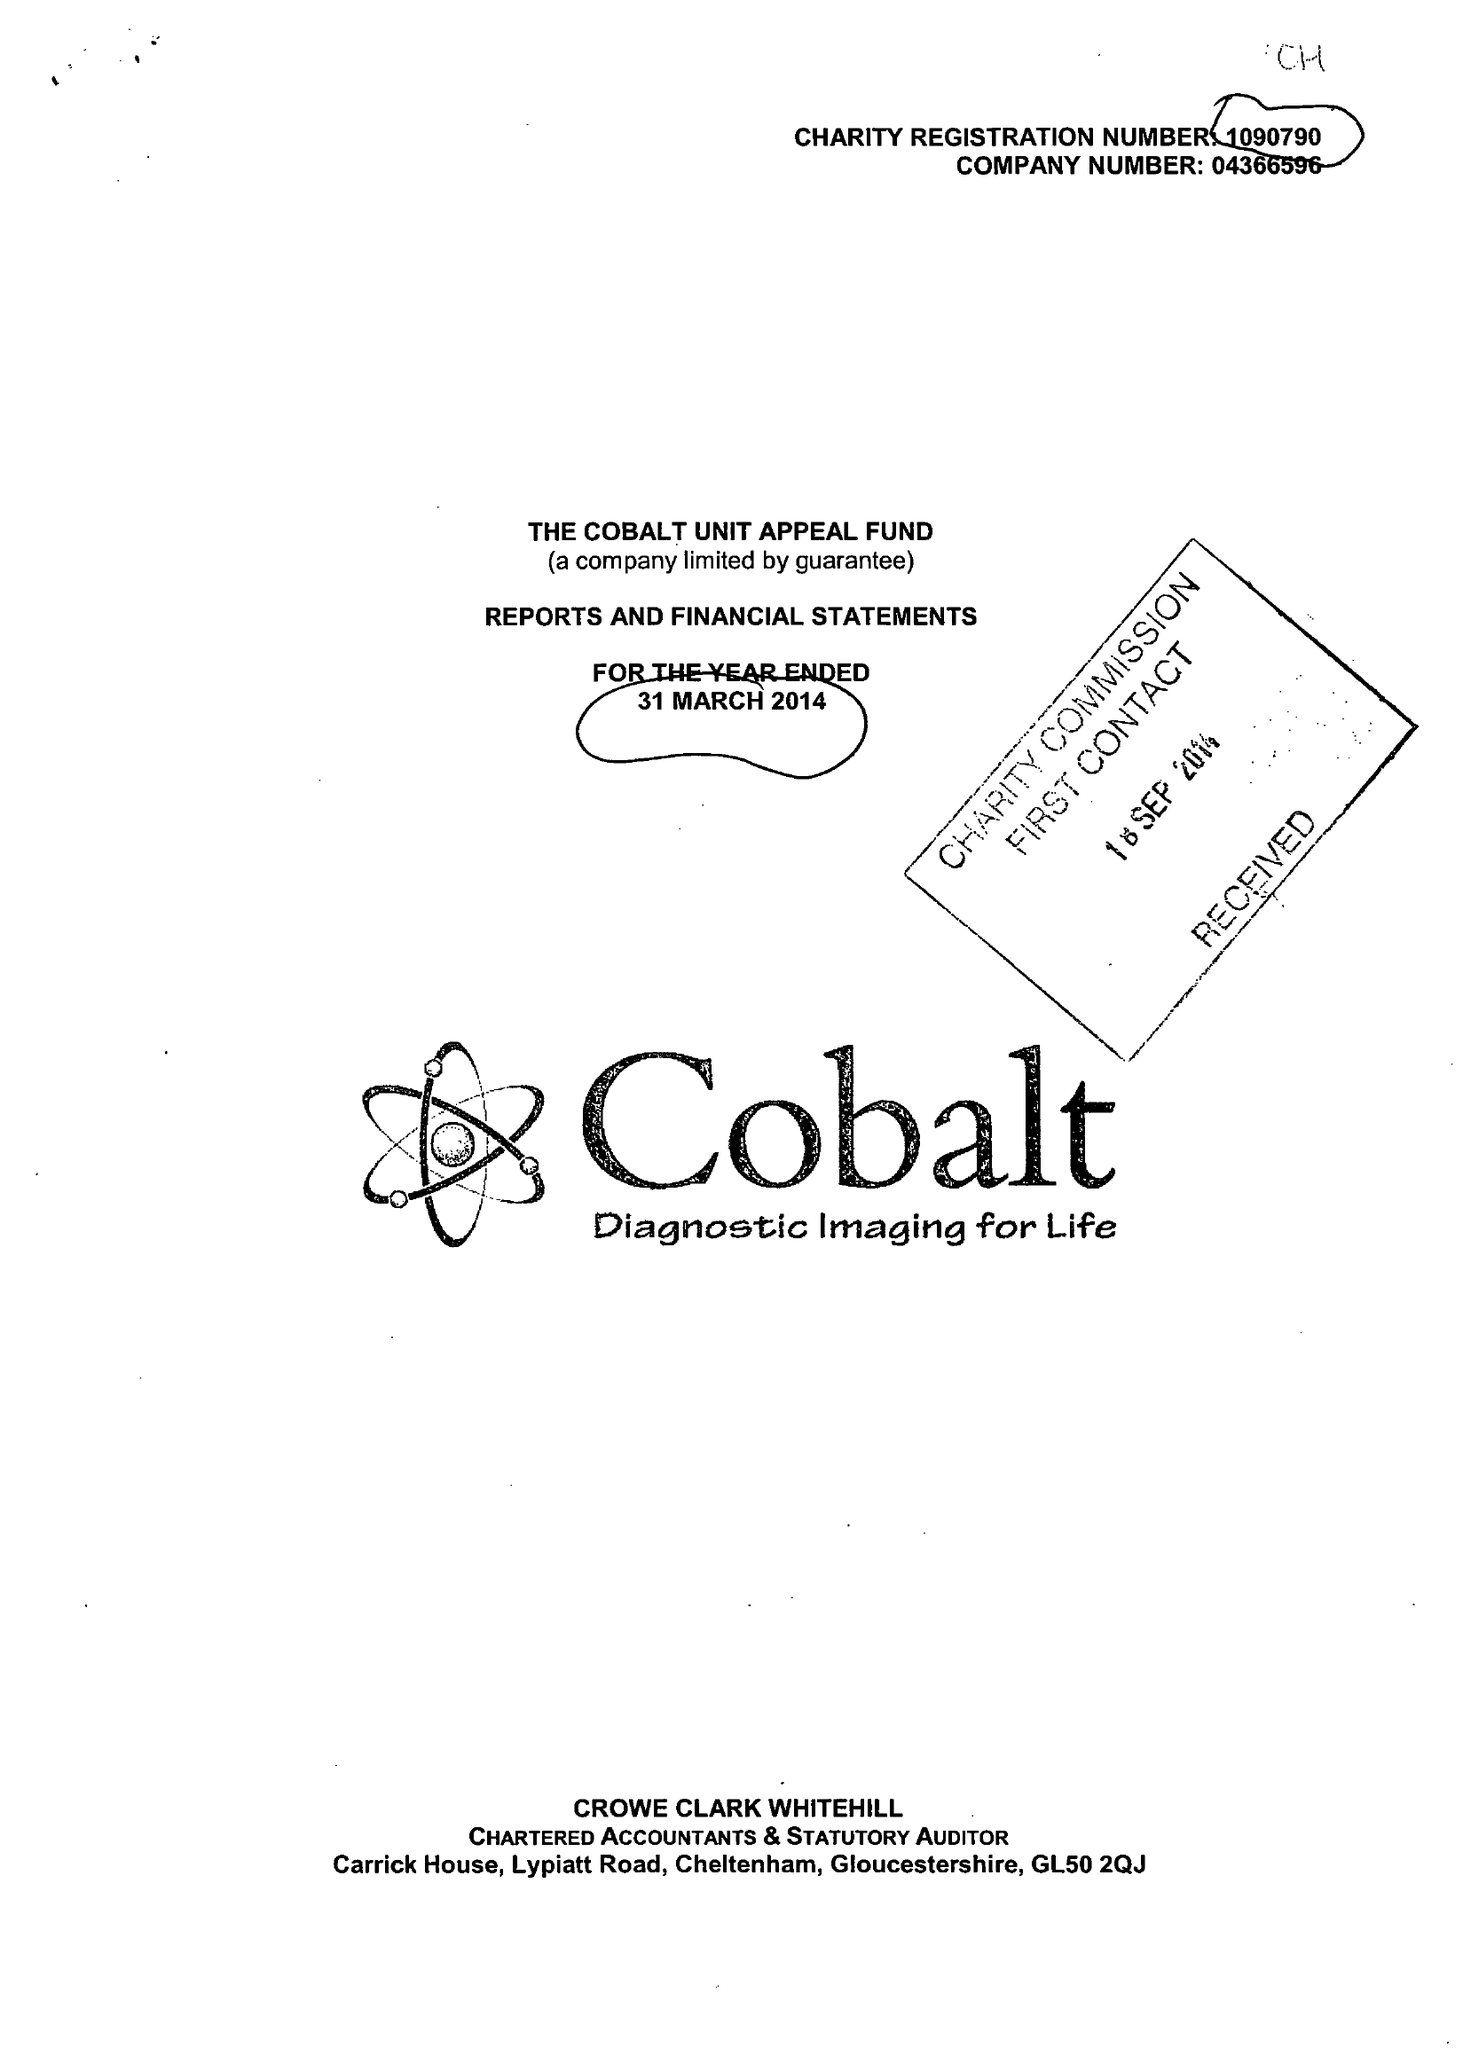What is the value for the income_annually_in_british_pounds?
Answer the question using a single word or phrase. 7892752.00 